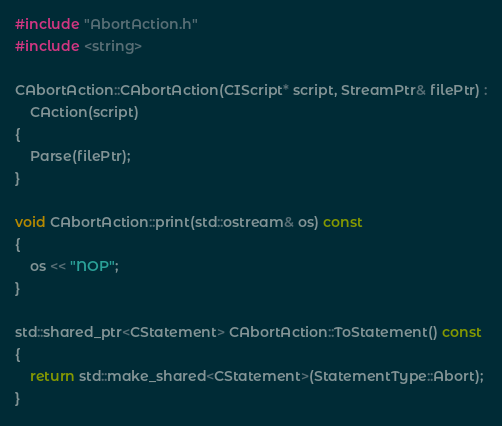<code> <loc_0><loc_0><loc_500><loc_500><_C++_>#include "AbortAction.h"
#include <string>

CAbortAction::CAbortAction(CIScript* script, StreamPtr& filePtr) :
	CAction(script)
{
	Parse(filePtr);
}

void CAbortAction::print(std::ostream& os) const
{
	os << "NOP";
}

std::shared_ptr<CStatement> CAbortAction::ToStatement() const
{
	return std::make_shared<CStatement>(StatementType::Abort);
}</code> 